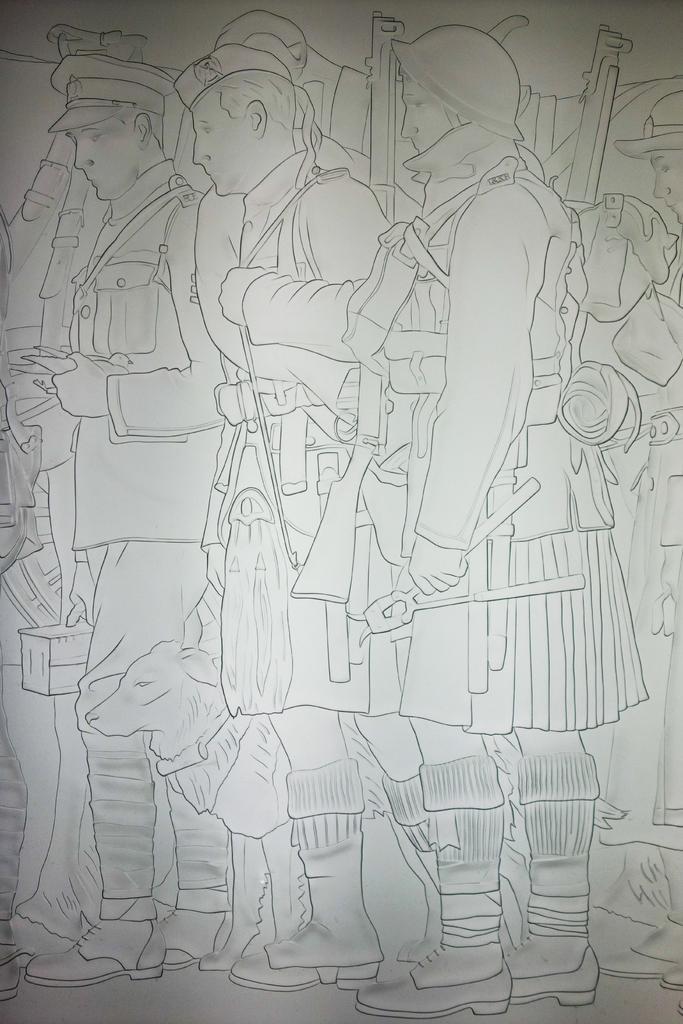Can you describe this image briefly? In this image I can see a sketch of dog and few people and they are holding something. Background is in white color. 